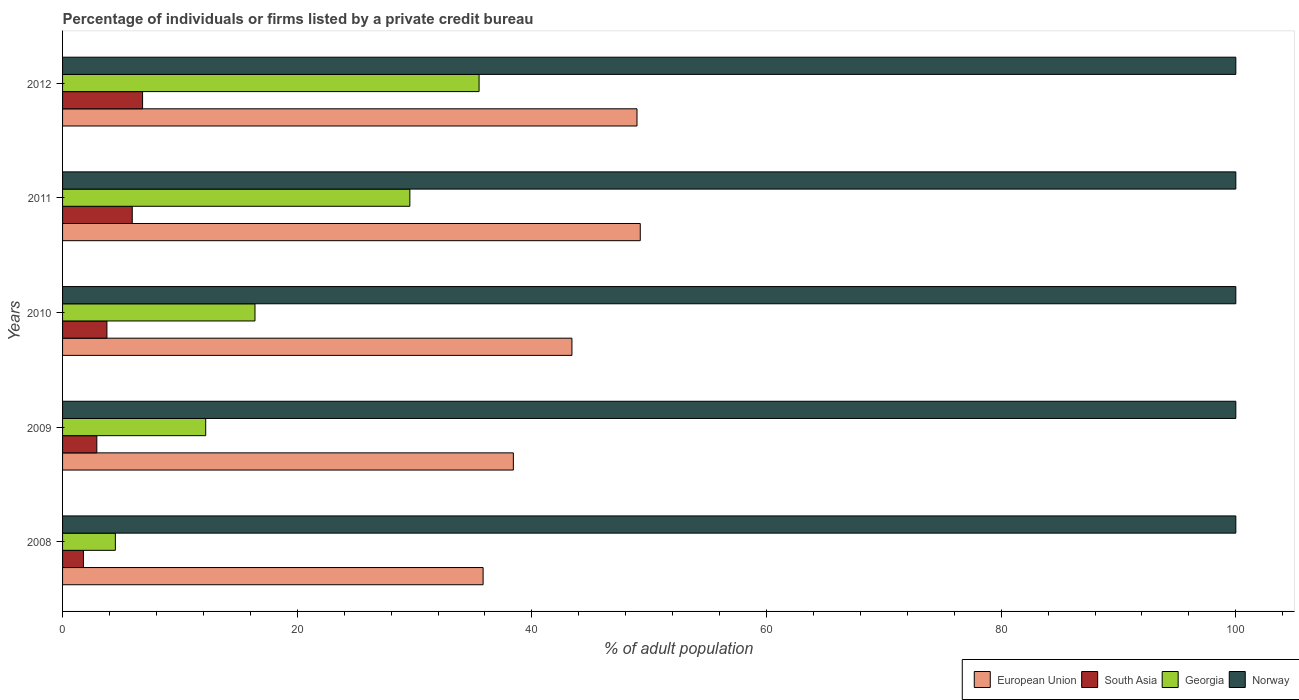How many different coloured bars are there?
Make the answer very short. 4. How many groups of bars are there?
Keep it short and to the point. 5. Are the number of bars per tick equal to the number of legend labels?
Offer a terse response. Yes. Are the number of bars on each tick of the Y-axis equal?
Make the answer very short. Yes. What is the label of the 4th group of bars from the top?
Your answer should be compact. 2009. In how many cases, is the number of bars for a given year not equal to the number of legend labels?
Ensure brevity in your answer.  0. What is the percentage of population listed by a private credit bureau in European Union in 2010?
Give a very brief answer. 43.41. Across all years, what is the maximum percentage of population listed by a private credit bureau in European Union?
Your answer should be compact. 49.24. Across all years, what is the minimum percentage of population listed by a private credit bureau in Norway?
Your response must be concise. 100. In which year was the percentage of population listed by a private credit bureau in Norway minimum?
Provide a succinct answer. 2008. What is the total percentage of population listed by a private credit bureau in Norway in the graph?
Your response must be concise. 500. What is the difference between the percentage of population listed by a private credit bureau in Georgia in 2011 and that in 2012?
Your answer should be compact. -5.9. What is the difference between the percentage of population listed by a private credit bureau in Georgia in 2011 and the percentage of population listed by a private credit bureau in Norway in 2012?
Provide a succinct answer. -70.4. What is the average percentage of population listed by a private credit bureau in Georgia per year?
Keep it short and to the point. 19.64. In the year 2010, what is the difference between the percentage of population listed by a private credit bureau in Georgia and percentage of population listed by a private credit bureau in European Union?
Ensure brevity in your answer.  -27.01. In how many years, is the percentage of population listed by a private credit bureau in Georgia greater than 88 %?
Give a very brief answer. 0. What is the ratio of the percentage of population listed by a private credit bureau in Georgia in 2009 to that in 2010?
Offer a very short reply. 0.74. Is the percentage of population listed by a private credit bureau in European Union in 2011 less than that in 2012?
Your answer should be very brief. No. Is the difference between the percentage of population listed by a private credit bureau in Georgia in 2009 and 2011 greater than the difference between the percentage of population listed by a private credit bureau in European Union in 2009 and 2011?
Your answer should be compact. No. What is the difference between the highest and the second highest percentage of population listed by a private credit bureau in European Union?
Your answer should be compact. 0.28. What is the difference between the highest and the lowest percentage of population listed by a private credit bureau in Georgia?
Offer a very short reply. 31. Is the sum of the percentage of population listed by a private credit bureau in European Union in 2008 and 2011 greater than the maximum percentage of population listed by a private credit bureau in South Asia across all years?
Provide a succinct answer. Yes. What does the 4th bar from the top in 2012 represents?
Provide a succinct answer. European Union. How many years are there in the graph?
Your answer should be very brief. 5. What is the difference between two consecutive major ticks on the X-axis?
Keep it short and to the point. 20. Are the values on the major ticks of X-axis written in scientific E-notation?
Ensure brevity in your answer.  No. Does the graph contain any zero values?
Provide a succinct answer. No. What is the title of the graph?
Ensure brevity in your answer.  Percentage of individuals or firms listed by a private credit bureau. Does "Kyrgyz Republic" appear as one of the legend labels in the graph?
Make the answer very short. No. What is the label or title of the X-axis?
Your response must be concise. % of adult population. What is the label or title of the Y-axis?
Offer a very short reply. Years. What is the % of adult population in European Union in 2008?
Provide a short and direct response. 35.84. What is the % of adult population in South Asia in 2008?
Ensure brevity in your answer.  1.78. What is the % of adult population in European Union in 2009?
Make the answer very short. 38.42. What is the % of adult population in South Asia in 2009?
Your answer should be very brief. 2.92. What is the % of adult population of European Union in 2010?
Provide a short and direct response. 43.41. What is the % of adult population of South Asia in 2010?
Your response must be concise. 3.78. What is the % of adult population of Georgia in 2010?
Give a very brief answer. 16.4. What is the % of adult population in European Union in 2011?
Your response must be concise. 49.24. What is the % of adult population in South Asia in 2011?
Ensure brevity in your answer.  5.94. What is the % of adult population of Georgia in 2011?
Your response must be concise. 29.6. What is the % of adult population in European Union in 2012?
Keep it short and to the point. 48.96. What is the % of adult population in South Asia in 2012?
Provide a succinct answer. 6.82. What is the % of adult population in Georgia in 2012?
Keep it short and to the point. 35.5. Across all years, what is the maximum % of adult population in European Union?
Provide a short and direct response. 49.24. Across all years, what is the maximum % of adult population in South Asia?
Make the answer very short. 6.82. Across all years, what is the maximum % of adult population of Georgia?
Give a very brief answer. 35.5. Across all years, what is the maximum % of adult population in Norway?
Your response must be concise. 100. Across all years, what is the minimum % of adult population in European Union?
Your response must be concise. 35.84. Across all years, what is the minimum % of adult population of South Asia?
Offer a very short reply. 1.78. What is the total % of adult population of European Union in the graph?
Your answer should be compact. 215.88. What is the total % of adult population of South Asia in the graph?
Give a very brief answer. 21.24. What is the total % of adult population of Georgia in the graph?
Ensure brevity in your answer.  98.2. What is the total % of adult population of Norway in the graph?
Give a very brief answer. 500. What is the difference between the % of adult population of European Union in 2008 and that in 2009?
Your answer should be very brief. -2.58. What is the difference between the % of adult population of South Asia in 2008 and that in 2009?
Make the answer very short. -1.14. What is the difference between the % of adult population in Georgia in 2008 and that in 2009?
Provide a succinct answer. -7.7. What is the difference between the % of adult population in European Union in 2008 and that in 2010?
Give a very brief answer. -7.57. What is the difference between the % of adult population of European Union in 2008 and that in 2011?
Provide a short and direct response. -13.39. What is the difference between the % of adult population in South Asia in 2008 and that in 2011?
Your answer should be compact. -4.16. What is the difference between the % of adult population in Georgia in 2008 and that in 2011?
Ensure brevity in your answer.  -25.1. What is the difference between the % of adult population of Norway in 2008 and that in 2011?
Keep it short and to the point. 0. What is the difference between the % of adult population of European Union in 2008 and that in 2012?
Provide a succinct answer. -13.12. What is the difference between the % of adult population in South Asia in 2008 and that in 2012?
Your response must be concise. -5.04. What is the difference between the % of adult population of Georgia in 2008 and that in 2012?
Keep it short and to the point. -31. What is the difference between the % of adult population of Norway in 2008 and that in 2012?
Provide a short and direct response. 0. What is the difference between the % of adult population in European Union in 2009 and that in 2010?
Ensure brevity in your answer.  -4.99. What is the difference between the % of adult population of South Asia in 2009 and that in 2010?
Make the answer very short. -0.86. What is the difference between the % of adult population of European Union in 2009 and that in 2011?
Keep it short and to the point. -10.82. What is the difference between the % of adult population in South Asia in 2009 and that in 2011?
Give a very brief answer. -3.02. What is the difference between the % of adult population in Georgia in 2009 and that in 2011?
Keep it short and to the point. -17.4. What is the difference between the % of adult population of European Union in 2009 and that in 2012?
Your response must be concise. -10.54. What is the difference between the % of adult population in Georgia in 2009 and that in 2012?
Provide a succinct answer. -23.3. What is the difference between the % of adult population in Norway in 2009 and that in 2012?
Provide a short and direct response. 0. What is the difference between the % of adult population in European Union in 2010 and that in 2011?
Offer a terse response. -5.82. What is the difference between the % of adult population of South Asia in 2010 and that in 2011?
Offer a very short reply. -2.16. What is the difference between the % of adult population in Georgia in 2010 and that in 2011?
Make the answer very short. -13.2. What is the difference between the % of adult population of European Union in 2010 and that in 2012?
Your answer should be very brief. -5.55. What is the difference between the % of adult population in South Asia in 2010 and that in 2012?
Your answer should be very brief. -3.04. What is the difference between the % of adult population in Georgia in 2010 and that in 2012?
Your answer should be compact. -19.1. What is the difference between the % of adult population of Norway in 2010 and that in 2012?
Offer a terse response. 0. What is the difference between the % of adult population in European Union in 2011 and that in 2012?
Keep it short and to the point. 0.28. What is the difference between the % of adult population in South Asia in 2011 and that in 2012?
Provide a short and direct response. -0.88. What is the difference between the % of adult population in European Union in 2008 and the % of adult population in South Asia in 2009?
Offer a very short reply. 32.92. What is the difference between the % of adult population of European Union in 2008 and the % of adult population of Georgia in 2009?
Offer a very short reply. 23.64. What is the difference between the % of adult population in European Union in 2008 and the % of adult population in Norway in 2009?
Give a very brief answer. -64.16. What is the difference between the % of adult population in South Asia in 2008 and the % of adult population in Georgia in 2009?
Give a very brief answer. -10.42. What is the difference between the % of adult population of South Asia in 2008 and the % of adult population of Norway in 2009?
Keep it short and to the point. -98.22. What is the difference between the % of adult population in Georgia in 2008 and the % of adult population in Norway in 2009?
Make the answer very short. -95.5. What is the difference between the % of adult population in European Union in 2008 and the % of adult population in South Asia in 2010?
Keep it short and to the point. 32.06. What is the difference between the % of adult population in European Union in 2008 and the % of adult population in Georgia in 2010?
Keep it short and to the point. 19.44. What is the difference between the % of adult population in European Union in 2008 and the % of adult population in Norway in 2010?
Offer a very short reply. -64.16. What is the difference between the % of adult population in South Asia in 2008 and the % of adult population in Georgia in 2010?
Your answer should be very brief. -14.62. What is the difference between the % of adult population in South Asia in 2008 and the % of adult population in Norway in 2010?
Provide a short and direct response. -98.22. What is the difference between the % of adult population of Georgia in 2008 and the % of adult population of Norway in 2010?
Ensure brevity in your answer.  -95.5. What is the difference between the % of adult population of European Union in 2008 and the % of adult population of South Asia in 2011?
Keep it short and to the point. 29.9. What is the difference between the % of adult population of European Union in 2008 and the % of adult population of Georgia in 2011?
Keep it short and to the point. 6.24. What is the difference between the % of adult population of European Union in 2008 and the % of adult population of Norway in 2011?
Give a very brief answer. -64.16. What is the difference between the % of adult population in South Asia in 2008 and the % of adult population in Georgia in 2011?
Offer a very short reply. -27.82. What is the difference between the % of adult population of South Asia in 2008 and the % of adult population of Norway in 2011?
Your response must be concise. -98.22. What is the difference between the % of adult population of Georgia in 2008 and the % of adult population of Norway in 2011?
Keep it short and to the point. -95.5. What is the difference between the % of adult population of European Union in 2008 and the % of adult population of South Asia in 2012?
Your answer should be compact. 29.02. What is the difference between the % of adult population of European Union in 2008 and the % of adult population of Georgia in 2012?
Provide a succinct answer. 0.34. What is the difference between the % of adult population of European Union in 2008 and the % of adult population of Norway in 2012?
Ensure brevity in your answer.  -64.16. What is the difference between the % of adult population in South Asia in 2008 and the % of adult population in Georgia in 2012?
Provide a short and direct response. -33.72. What is the difference between the % of adult population in South Asia in 2008 and the % of adult population in Norway in 2012?
Offer a terse response. -98.22. What is the difference between the % of adult population of Georgia in 2008 and the % of adult population of Norway in 2012?
Your answer should be very brief. -95.5. What is the difference between the % of adult population in European Union in 2009 and the % of adult population in South Asia in 2010?
Provide a short and direct response. 34.64. What is the difference between the % of adult population of European Union in 2009 and the % of adult population of Georgia in 2010?
Your answer should be very brief. 22.02. What is the difference between the % of adult population of European Union in 2009 and the % of adult population of Norway in 2010?
Ensure brevity in your answer.  -61.58. What is the difference between the % of adult population in South Asia in 2009 and the % of adult population in Georgia in 2010?
Offer a very short reply. -13.48. What is the difference between the % of adult population of South Asia in 2009 and the % of adult population of Norway in 2010?
Give a very brief answer. -97.08. What is the difference between the % of adult population in Georgia in 2009 and the % of adult population in Norway in 2010?
Keep it short and to the point. -87.8. What is the difference between the % of adult population of European Union in 2009 and the % of adult population of South Asia in 2011?
Keep it short and to the point. 32.48. What is the difference between the % of adult population of European Union in 2009 and the % of adult population of Georgia in 2011?
Provide a short and direct response. 8.82. What is the difference between the % of adult population of European Union in 2009 and the % of adult population of Norway in 2011?
Your answer should be very brief. -61.58. What is the difference between the % of adult population in South Asia in 2009 and the % of adult population in Georgia in 2011?
Offer a very short reply. -26.68. What is the difference between the % of adult population of South Asia in 2009 and the % of adult population of Norway in 2011?
Keep it short and to the point. -97.08. What is the difference between the % of adult population in Georgia in 2009 and the % of adult population in Norway in 2011?
Provide a succinct answer. -87.8. What is the difference between the % of adult population of European Union in 2009 and the % of adult population of South Asia in 2012?
Your answer should be compact. 31.6. What is the difference between the % of adult population of European Union in 2009 and the % of adult population of Georgia in 2012?
Ensure brevity in your answer.  2.92. What is the difference between the % of adult population in European Union in 2009 and the % of adult population in Norway in 2012?
Make the answer very short. -61.58. What is the difference between the % of adult population of South Asia in 2009 and the % of adult population of Georgia in 2012?
Provide a succinct answer. -32.58. What is the difference between the % of adult population of South Asia in 2009 and the % of adult population of Norway in 2012?
Ensure brevity in your answer.  -97.08. What is the difference between the % of adult population of Georgia in 2009 and the % of adult population of Norway in 2012?
Give a very brief answer. -87.8. What is the difference between the % of adult population of European Union in 2010 and the % of adult population of South Asia in 2011?
Keep it short and to the point. 37.47. What is the difference between the % of adult population of European Union in 2010 and the % of adult population of Georgia in 2011?
Offer a terse response. 13.81. What is the difference between the % of adult population of European Union in 2010 and the % of adult population of Norway in 2011?
Offer a very short reply. -56.59. What is the difference between the % of adult population of South Asia in 2010 and the % of adult population of Georgia in 2011?
Keep it short and to the point. -25.82. What is the difference between the % of adult population in South Asia in 2010 and the % of adult population in Norway in 2011?
Offer a terse response. -96.22. What is the difference between the % of adult population in Georgia in 2010 and the % of adult population in Norway in 2011?
Make the answer very short. -83.6. What is the difference between the % of adult population in European Union in 2010 and the % of adult population in South Asia in 2012?
Give a very brief answer. 36.59. What is the difference between the % of adult population in European Union in 2010 and the % of adult population in Georgia in 2012?
Your response must be concise. 7.91. What is the difference between the % of adult population in European Union in 2010 and the % of adult population in Norway in 2012?
Offer a very short reply. -56.59. What is the difference between the % of adult population in South Asia in 2010 and the % of adult population in Georgia in 2012?
Your answer should be very brief. -31.72. What is the difference between the % of adult population of South Asia in 2010 and the % of adult population of Norway in 2012?
Provide a succinct answer. -96.22. What is the difference between the % of adult population in Georgia in 2010 and the % of adult population in Norway in 2012?
Your response must be concise. -83.6. What is the difference between the % of adult population in European Union in 2011 and the % of adult population in South Asia in 2012?
Provide a short and direct response. 42.42. What is the difference between the % of adult population in European Union in 2011 and the % of adult population in Georgia in 2012?
Ensure brevity in your answer.  13.74. What is the difference between the % of adult population in European Union in 2011 and the % of adult population in Norway in 2012?
Your answer should be very brief. -50.76. What is the difference between the % of adult population in South Asia in 2011 and the % of adult population in Georgia in 2012?
Make the answer very short. -29.56. What is the difference between the % of adult population in South Asia in 2011 and the % of adult population in Norway in 2012?
Provide a short and direct response. -94.06. What is the difference between the % of adult population of Georgia in 2011 and the % of adult population of Norway in 2012?
Offer a very short reply. -70.4. What is the average % of adult population in European Union per year?
Ensure brevity in your answer.  43.18. What is the average % of adult population of South Asia per year?
Give a very brief answer. 4.25. What is the average % of adult population of Georgia per year?
Provide a succinct answer. 19.64. What is the average % of adult population of Norway per year?
Make the answer very short. 100. In the year 2008, what is the difference between the % of adult population in European Union and % of adult population in South Asia?
Your response must be concise. 34.06. In the year 2008, what is the difference between the % of adult population of European Union and % of adult population of Georgia?
Your answer should be very brief. 31.34. In the year 2008, what is the difference between the % of adult population of European Union and % of adult population of Norway?
Your answer should be compact. -64.16. In the year 2008, what is the difference between the % of adult population in South Asia and % of adult population in Georgia?
Make the answer very short. -2.72. In the year 2008, what is the difference between the % of adult population of South Asia and % of adult population of Norway?
Make the answer very short. -98.22. In the year 2008, what is the difference between the % of adult population of Georgia and % of adult population of Norway?
Provide a short and direct response. -95.5. In the year 2009, what is the difference between the % of adult population in European Union and % of adult population in South Asia?
Provide a short and direct response. 35.5. In the year 2009, what is the difference between the % of adult population in European Union and % of adult population in Georgia?
Give a very brief answer. 26.22. In the year 2009, what is the difference between the % of adult population in European Union and % of adult population in Norway?
Your answer should be very brief. -61.58. In the year 2009, what is the difference between the % of adult population in South Asia and % of adult population in Georgia?
Give a very brief answer. -9.28. In the year 2009, what is the difference between the % of adult population of South Asia and % of adult population of Norway?
Your answer should be compact. -97.08. In the year 2009, what is the difference between the % of adult population of Georgia and % of adult population of Norway?
Offer a very short reply. -87.8. In the year 2010, what is the difference between the % of adult population in European Union and % of adult population in South Asia?
Ensure brevity in your answer.  39.63. In the year 2010, what is the difference between the % of adult population of European Union and % of adult population of Georgia?
Make the answer very short. 27.01. In the year 2010, what is the difference between the % of adult population in European Union and % of adult population in Norway?
Give a very brief answer. -56.59. In the year 2010, what is the difference between the % of adult population of South Asia and % of adult population of Georgia?
Ensure brevity in your answer.  -12.62. In the year 2010, what is the difference between the % of adult population of South Asia and % of adult population of Norway?
Give a very brief answer. -96.22. In the year 2010, what is the difference between the % of adult population of Georgia and % of adult population of Norway?
Your answer should be very brief. -83.6. In the year 2011, what is the difference between the % of adult population in European Union and % of adult population in South Asia?
Ensure brevity in your answer.  43.3. In the year 2011, what is the difference between the % of adult population of European Union and % of adult population of Georgia?
Offer a terse response. 19.64. In the year 2011, what is the difference between the % of adult population in European Union and % of adult population in Norway?
Ensure brevity in your answer.  -50.76. In the year 2011, what is the difference between the % of adult population in South Asia and % of adult population in Georgia?
Your response must be concise. -23.66. In the year 2011, what is the difference between the % of adult population of South Asia and % of adult population of Norway?
Offer a terse response. -94.06. In the year 2011, what is the difference between the % of adult population of Georgia and % of adult population of Norway?
Make the answer very short. -70.4. In the year 2012, what is the difference between the % of adult population in European Union and % of adult population in South Asia?
Your answer should be very brief. 42.14. In the year 2012, what is the difference between the % of adult population in European Union and % of adult population in Georgia?
Keep it short and to the point. 13.46. In the year 2012, what is the difference between the % of adult population in European Union and % of adult population in Norway?
Ensure brevity in your answer.  -51.04. In the year 2012, what is the difference between the % of adult population in South Asia and % of adult population in Georgia?
Provide a short and direct response. -28.68. In the year 2012, what is the difference between the % of adult population in South Asia and % of adult population in Norway?
Keep it short and to the point. -93.18. In the year 2012, what is the difference between the % of adult population in Georgia and % of adult population in Norway?
Ensure brevity in your answer.  -64.5. What is the ratio of the % of adult population of European Union in 2008 to that in 2009?
Keep it short and to the point. 0.93. What is the ratio of the % of adult population in South Asia in 2008 to that in 2009?
Your answer should be very brief. 0.61. What is the ratio of the % of adult population of Georgia in 2008 to that in 2009?
Offer a terse response. 0.37. What is the ratio of the % of adult population of Norway in 2008 to that in 2009?
Give a very brief answer. 1. What is the ratio of the % of adult population in European Union in 2008 to that in 2010?
Provide a succinct answer. 0.83. What is the ratio of the % of adult population in South Asia in 2008 to that in 2010?
Offer a terse response. 0.47. What is the ratio of the % of adult population of Georgia in 2008 to that in 2010?
Your answer should be compact. 0.27. What is the ratio of the % of adult population in European Union in 2008 to that in 2011?
Provide a short and direct response. 0.73. What is the ratio of the % of adult population of South Asia in 2008 to that in 2011?
Ensure brevity in your answer.  0.3. What is the ratio of the % of adult population in Georgia in 2008 to that in 2011?
Make the answer very short. 0.15. What is the ratio of the % of adult population in European Union in 2008 to that in 2012?
Keep it short and to the point. 0.73. What is the ratio of the % of adult population of South Asia in 2008 to that in 2012?
Provide a succinct answer. 0.26. What is the ratio of the % of adult population of Georgia in 2008 to that in 2012?
Make the answer very short. 0.13. What is the ratio of the % of adult population of European Union in 2009 to that in 2010?
Give a very brief answer. 0.89. What is the ratio of the % of adult population in South Asia in 2009 to that in 2010?
Provide a short and direct response. 0.77. What is the ratio of the % of adult population in Georgia in 2009 to that in 2010?
Your answer should be very brief. 0.74. What is the ratio of the % of adult population in European Union in 2009 to that in 2011?
Offer a very short reply. 0.78. What is the ratio of the % of adult population in South Asia in 2009 to that in 2011?
Ensure brevity in your answer.  0.49. What is the ratio of the % of adult population of Georgia in 2009 to that in 2011?
Make the answer very short. 0.41. What is the ratio of the % of adult population of European Union in 2009 to that in 2012?
Provide a succinct answer. 0.78. What is the ratio of the % of adult population of South Asia in 2009 to that in 2012?
Offer a terse response. 0.43. What is the ratio of the % of adult population in Georgia in 2009 to that in 2012?
Offer a terse response. 0.34. What is the ratio of the % of adult population in Norway in 2009 to that in 2012?
Give a very brief answer. 1. What is the ratio of the % of adult population in European Union in 2010 to that in 2011?
Your answer should be very brief. 0.88. What is the ratio of the % of adult population in South Asia in 2010 to that in 2011?
Provide a succinct answer. 0.64. What is the ratio of the % of adult population in Georgia in 2010 to that in 2011?
Your answer should be compact. 0.55. What is the ratio of the % of adult population of Norway in 2010 to that in 2011?
Provide a short and direct response. 1. What is the ratio of the % of adult population of European Union in 2010 to that in 2012?
Give a very brief answer. 0.89. What is the ratio of the % of adult population of South Asia in 2010 to that in 2012?
Offer a very short reply. 0.55. What is the ratio of the % of adult population of Georgia in 2010 to that in 2012?
Your answer should be compact. 0.46. What is the ratio of the % of adult population in Norway in 2010 to that in 2012?
Your response must be concise. 1. What is the ratio of the % of adult population in European Union in 2011 to that in 2012?
Ensure brevity in your answer.  1.01. What is the ratio of the % of adult population of South Asia in 2011 to that in 2012?
Offer a very short reply. 0.87. What is the ratio of the % of adult population of Georgia in 2011 to that in 2012?
Provide a succinct answer. 0.83. What is the difference between the highest and the second highest % of adult population in European Union?
Provide a short and direct response. 0.28. What is the difference between the highest and the lowest % of adult population of European Union?
Give a very brief answer. 13.39. What is the difference between the highest and the lowest % of adult population of South Asia?
Your response must be concise. 5.04. What is the difference between the highest and the lowest % of adult population in Georgia?
Offer a terse response. 31. 